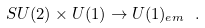<formula> <loc_0><loc_0><loc_500><loc_500>S U ( 2 ) \times U ( 1 ) \rightarrow U ( 1 ) _ { e m } \ .</formula> 